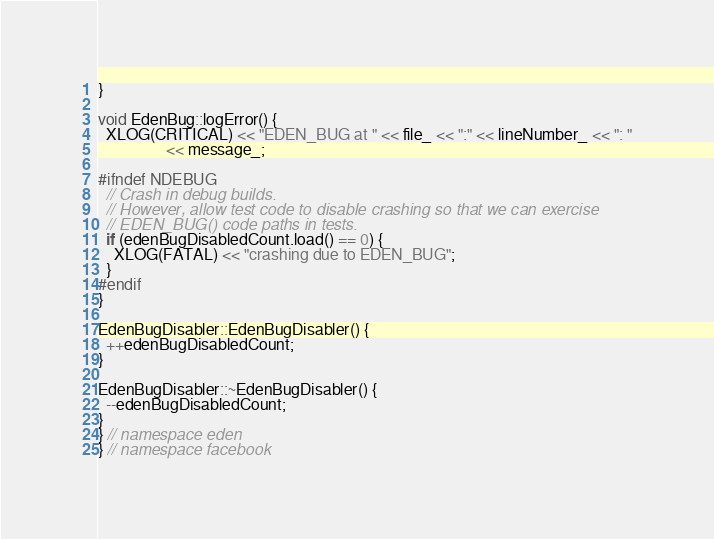<code> <loc_0><loc_0><loc_500><loc_500><_C++_>}

void EdenBug::logError() {
  XLOG(CRITICAL) << "EDEN_BUG at " << file_ << ":" << lineNumber_ << ": "
                 << message_;

#ifndef NDEBUG
  // Crash in debug builds.
  // However, allow test code to disable crashing so that we can exercise
  // EDEN_BUG() code paths in tests.
  if (edenBugDisabledCount.load() == 0) {
    XLOG(FATAL) << "crashing due to EDEN_BUG";
  }
#endif
}

EdenBugDisabler::EdenBugDisabler() {
  ++edenBugDisabledCount;
}

EdenBugDisabler::~EdenBugDisabler() {
  --edenBugDisabledCount;
}
} // namespace eden
} // namespace facebook
</code> 